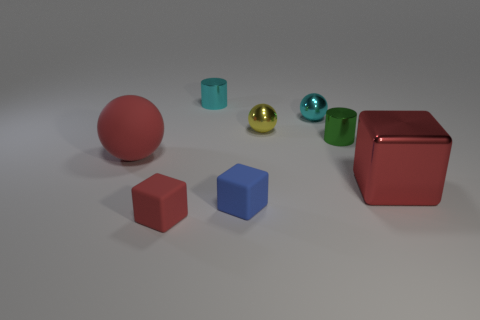What is the color of the other tiny object that is the same shape as the tiny red thing?
Keep it short and to the point. Blue. What number of tiny things are red things or red matte spheres?
Give a very brief answer. 1. There is a red object right of the tiny green thing; how big is it?
Your answer should be very brief. Large. Are there any things of the same color as the big rubber sphere?
Ensure brevity in your answer.  Yes. Is the color of the big metal object the same as the big matte object?
Offer a terse response. Yes. What is the shape of the small thing that is the same color as the large cube?
Provide a short and direct response. Cube. What number of blue rubber blocks are in front of the small matte cube that is behind the small red matte block?
Give a very brief answer. 0. What number of big balls have the same material as the green cylinder?
Offer a terse response. 0. Are there any tiny green shiny cylinders behind the big matte object?
Your answer should be very brief. Yes. There is a ball that is the same size as the yellow shiny object; what color is it?
Your answer should be very brief. Cyan. 